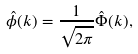Convert formula to latex. <formula><loc_0><loc_0><loc_500><loc_500>\hat { \phi } ( k ) = \frac { 1 } { \sqrt { 2 \pi } } \hat { \Phi } ( k ) ,</formula> 